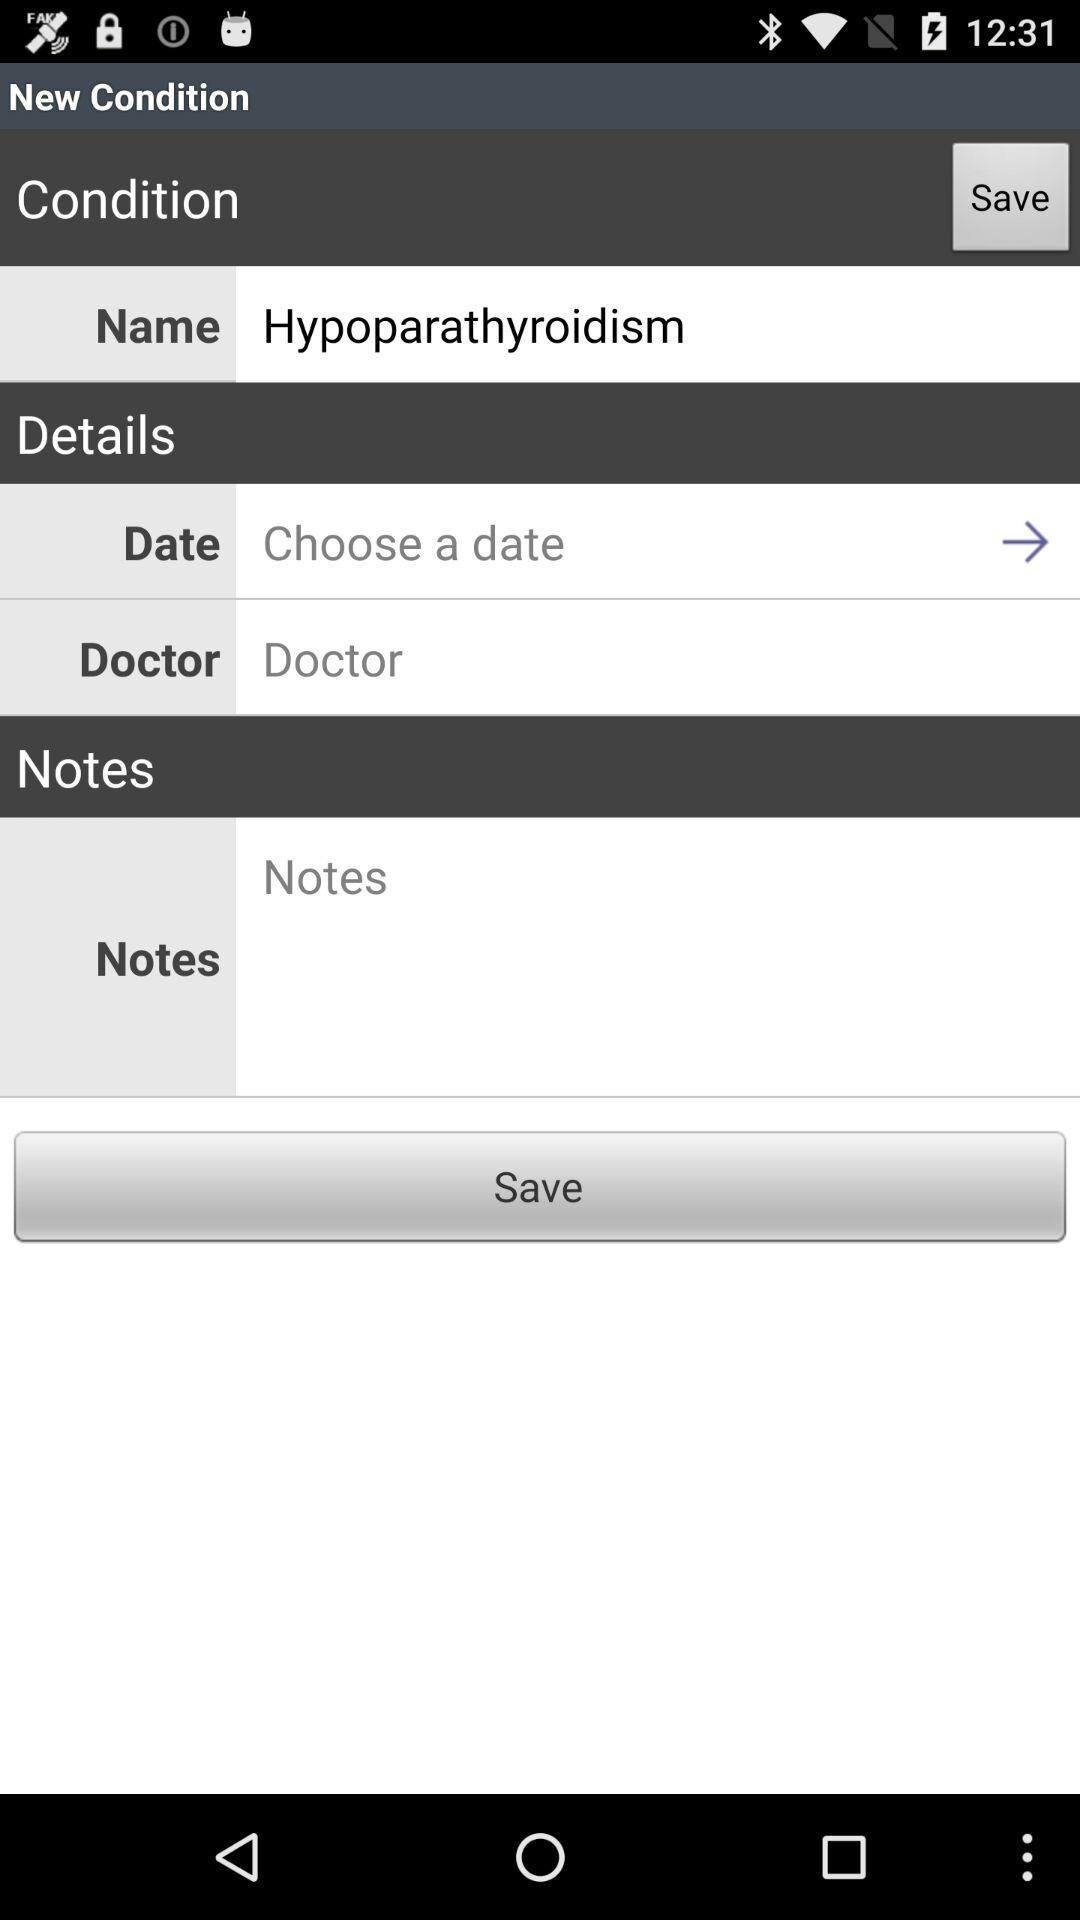What is the name of this condition? The name of this condition is "Hypoparathyroidism". 